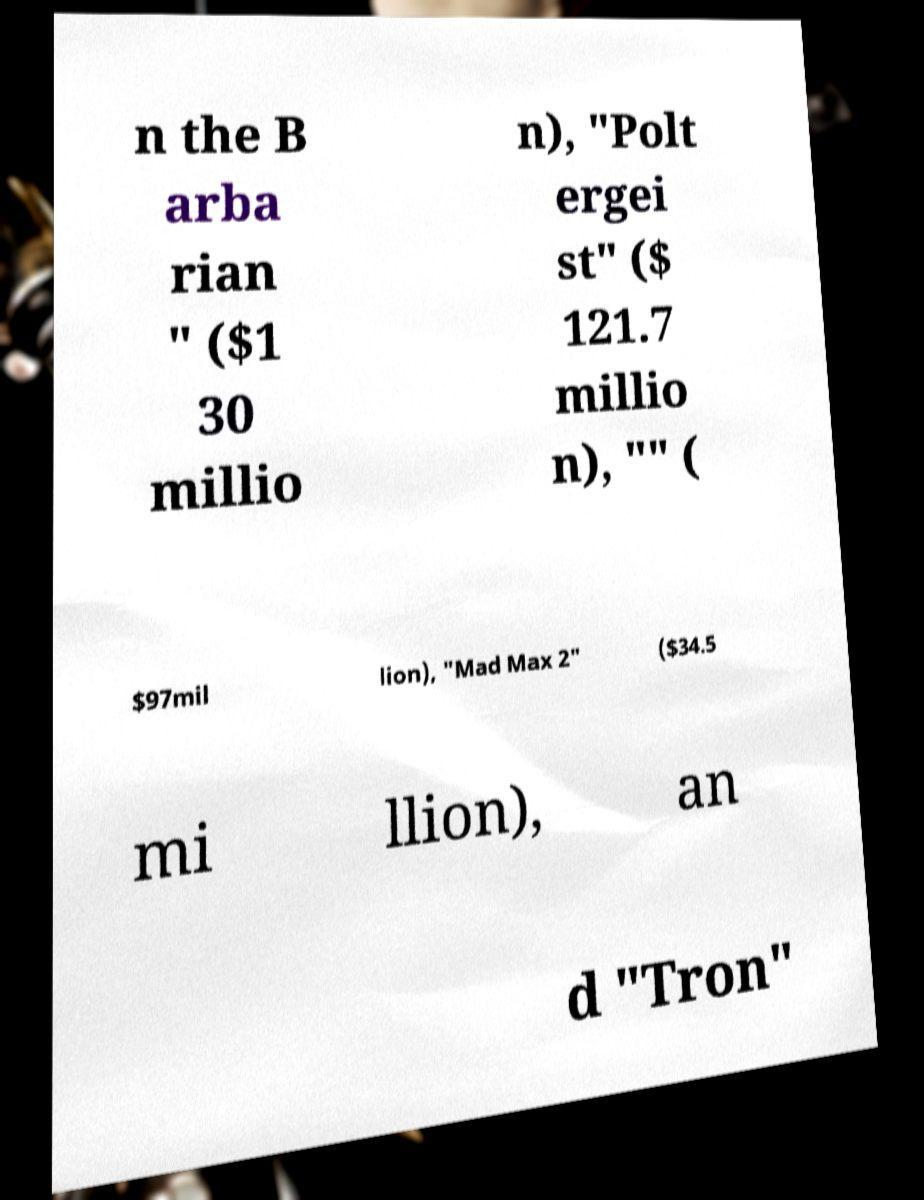For documentation purposes, I need the text within this image transcribed. Could you provide that? n the B arba rian " ($1 30 millio n), "Polt ergei st" ($ 121.7 millio n), "" ( $97mil lion), "Mad Max 2" ($34.5 mi llion), an d "Tron" 